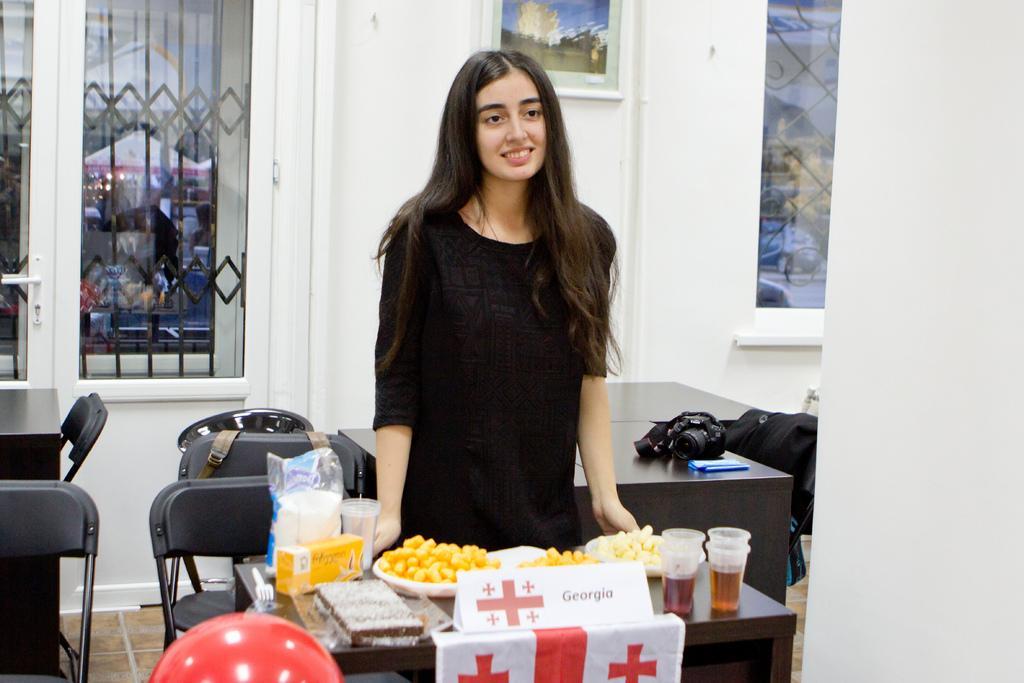Can you describe this image briefly? A girl is standing at a table with some eatables on it. 